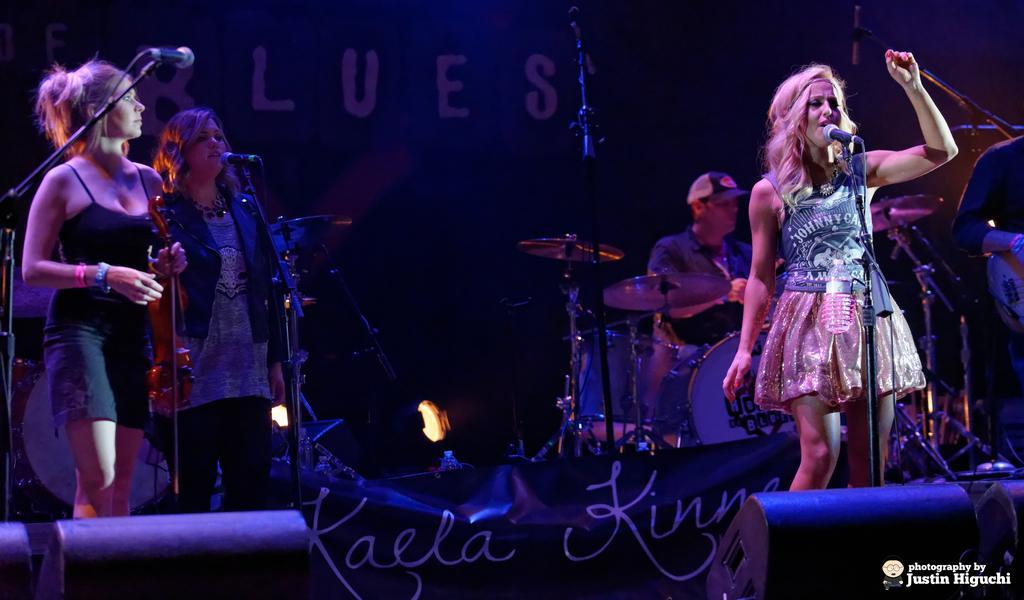How would you summarize this image in a sentence or two? This image is taken in a concert. In the background there is a banner with a text on it. At the bottom of the image there is a dais and there is another banner with a text on it and there are a few lights. On the left side of the image two women are standing on the dais and there are a few mics. On the right side of the image a man is sitting on the chair and there are a few musical instruments. A woman is standing on the dais and she is singing and there's a mic. 